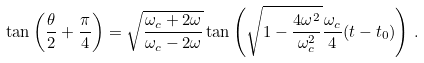<formula> <loc_0><loc_0><loc_500><loc_500>\tan \left ( \frac { \theta } { 2 } + \frac { \pi } { 4 } \right ) = \sqrt { \frac { \omega _ { c } + 2 \omega } { \omega _ { c } - 2 \omega } } \tan \left ( \sqrt { 1 - \frac { 4 \omega ^ { 2 } } { \omega _ { c } ^ { 2 } } } \frac { \omega _ { c } } { 4 } ( t - t _ { 0 } ) \right ) \, .</formula> 